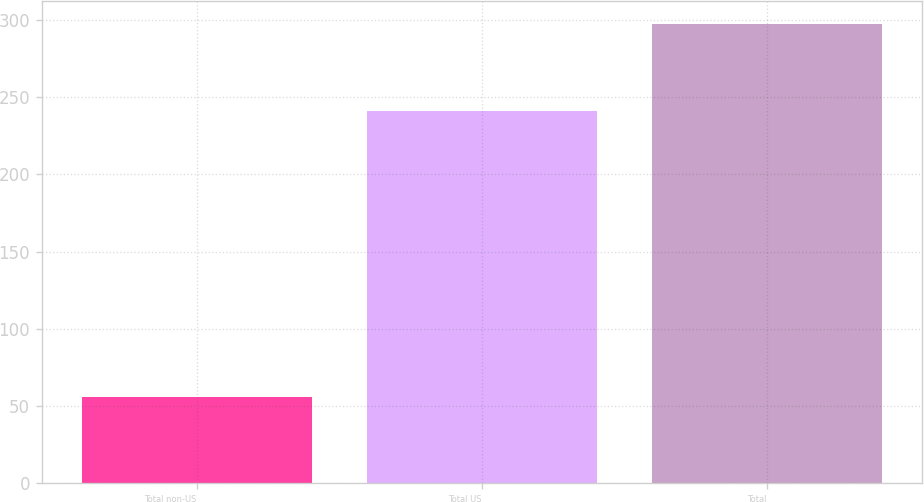<chart> <loc_0><loc_0><loc_500><loc_500><bar_chart><fcel>Total non-US<fcel>Total US<fcel>Total<nl><fcel>56<fcel>241<fcel>297<nl></chart> 